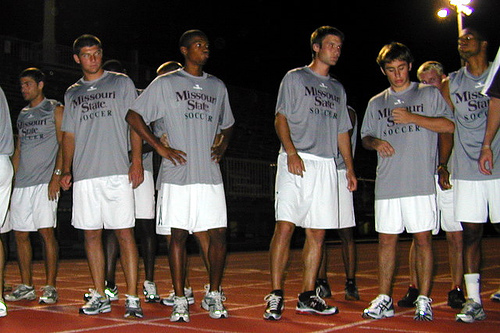<image>
Is there a man on the man? No. The man is not positioned on the man. They may be near each other, but the man is not supported by or resting on top of the man. Is there a shoe in front of the man? No. The shoe is not in front of the man. The spatial positioning shows a different relationship between these objects. 